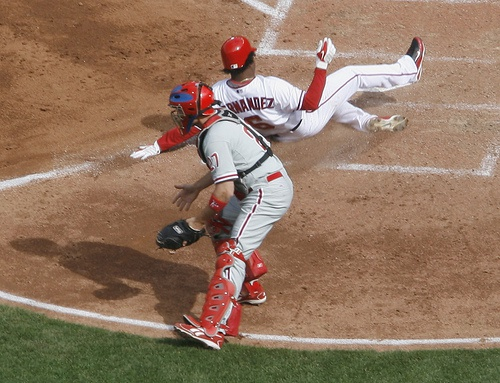Describe the objects in this image and their specific colors. I can see people in brown, lightgray, darkgray, and maroon tones, people in brown, lavender, darkgray, and gray tones, and baseball glove in brown, black, gray, and darkgray tones in this image. 